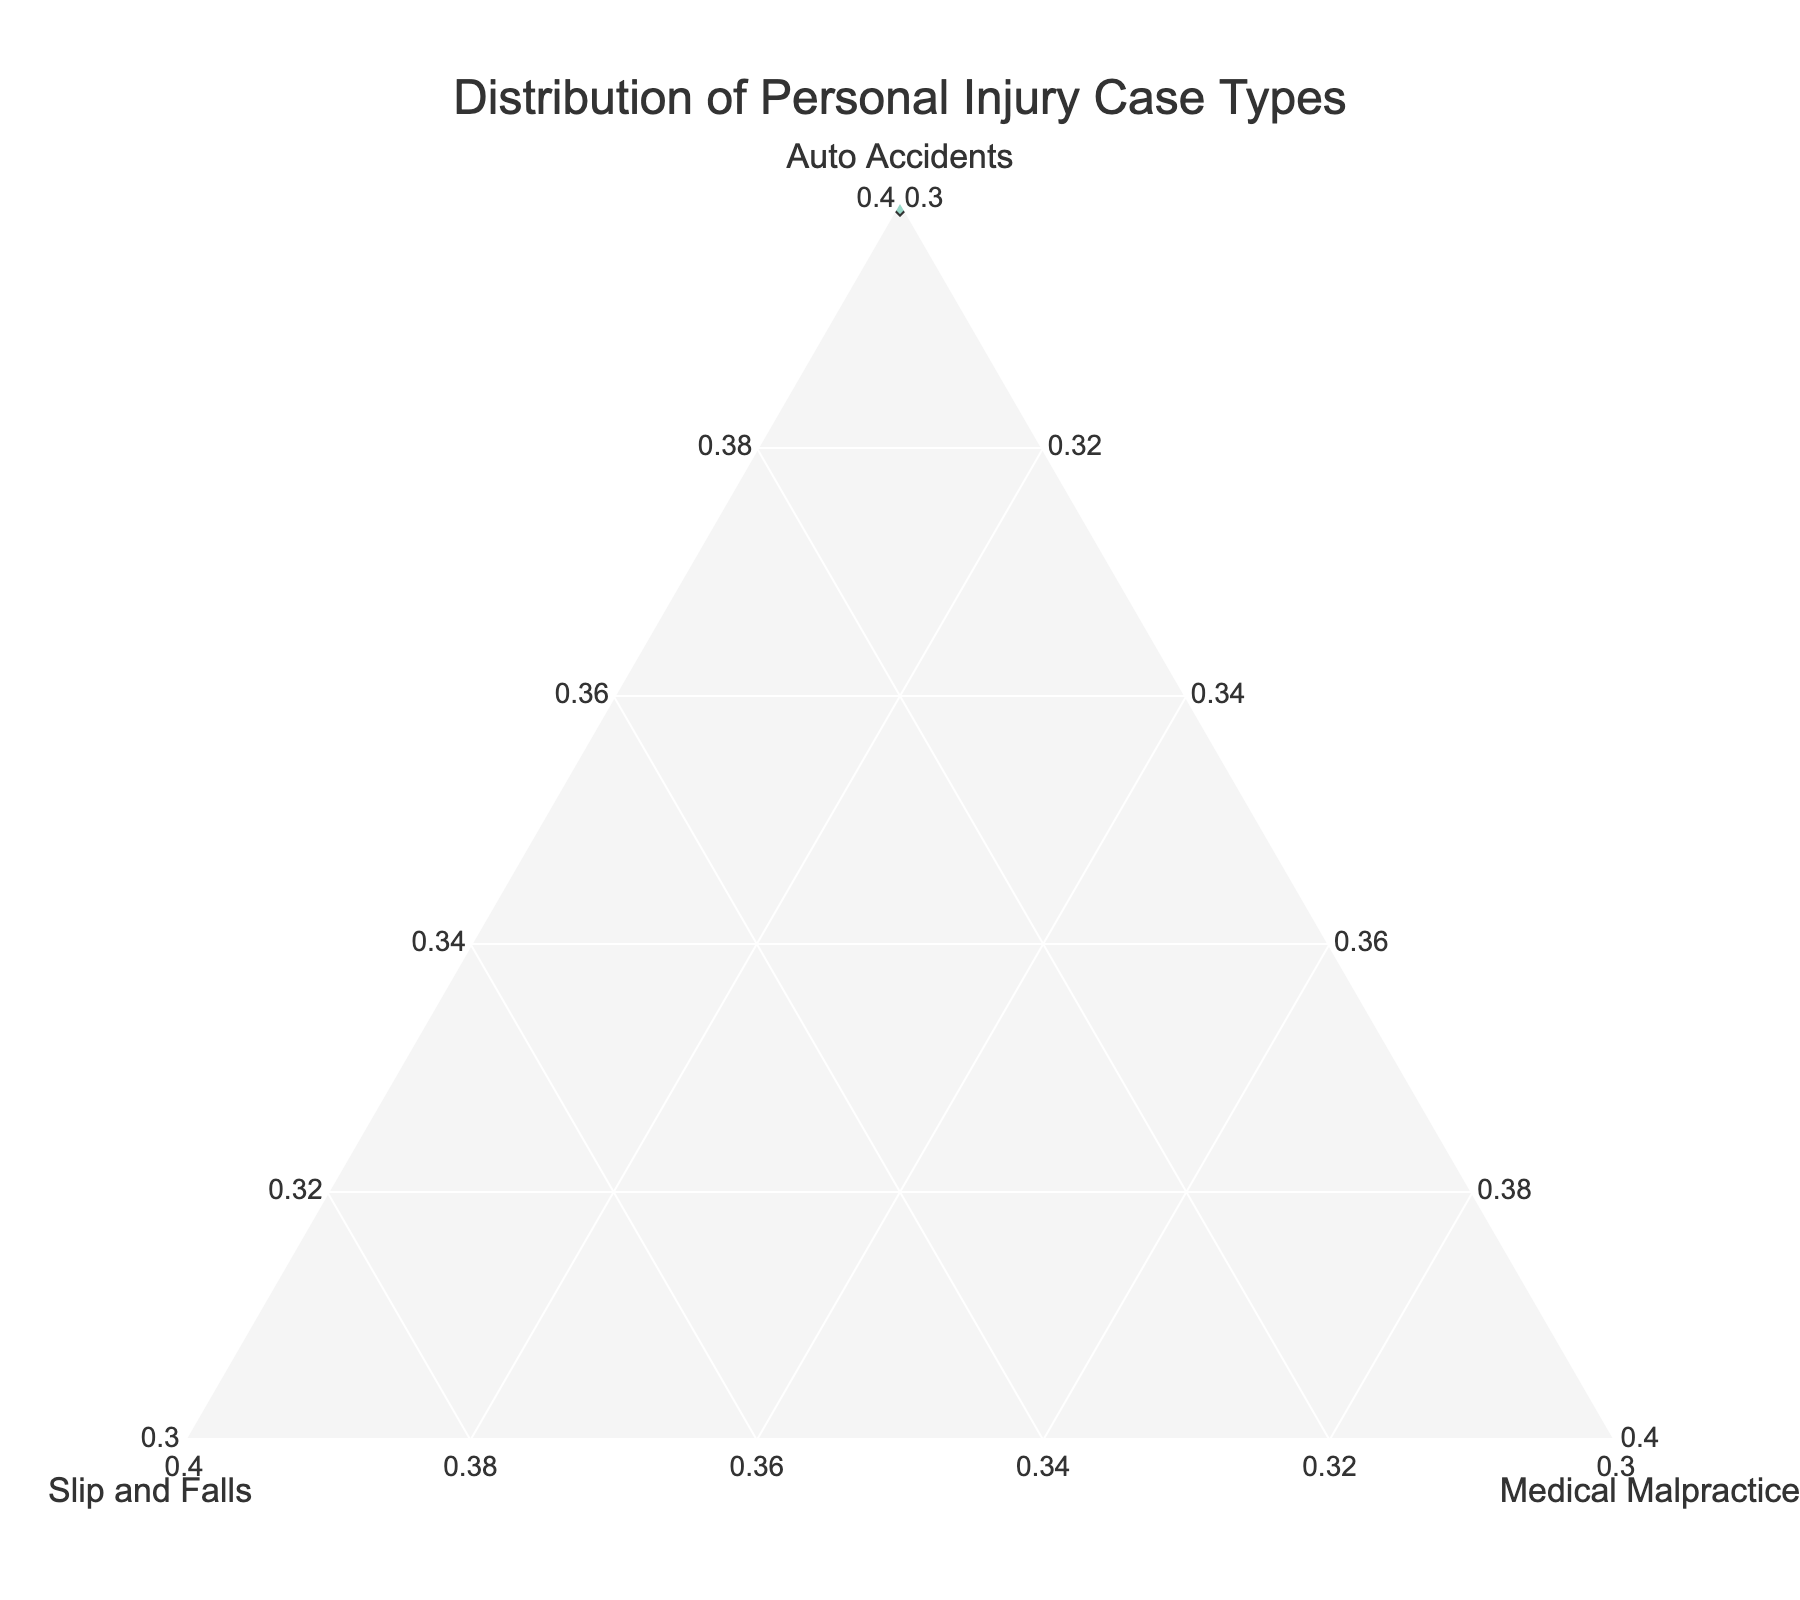What's the title of the ternary plot? The title of a plot is generally at the top and summarizes what the plot represents. In this case, the plot title is "Distribution of Personal Injury Case Types."
Answer: "Distribution of Personal Injury Case Types" How many law firms are plotted in the ternary plot? The figure plots individual data points marked with firm names. By counting these labels, we can determine that there are 10 points.
Answer: 10 Which law firm has the highest percentage of Auto Accidents cases? To determine this, look for the most skewed point towards the "Auto Accidents" axis. The firm "Chen Law Office" has the highest percentage at 65%.
Answer: Chen Law Office What is the proportion of Medical Malpractice cases for the "Goldstein Firm"? Find the "Goldstein Firm" label and check its position with respect to the Medical Malpractice axis. The firm has 30% of its cases in Medical Malpractice.
Answer: 30% Which two law firms have the same percentage of Medical Malpractice cases? Look for firms with identical values on the Medical Malpractice axis. Both "Johnson & Associates" and "Hernandez Law Group" have 15% of their cases in Medical Malpractice.
Answer: Johnson & Associates and Hernandez Law Group Do any law firms have an equal distribution in Slip and Falls and Medical Malpractice cases? Observe the ternary plot and compare values on both "Slip and Falls" and "Medical Malpractice" axes. None of the firms have equal distribution across these two case types.
Answer: No Which law firm has the closest distribution of case types to the center of the plot? The center of the ternary plot represents an equal distribution across all three categories. The "Goldstein Firm" with values (40, 30, 30) appears closest to the center.
Answer: Goldstein Firm Calculate the total percentage of non-Auto Accident cases for "Rodriguez & Partners." Sum the percentages for "Slip and Falls" and "Medical Malpractice." For "Rodriguez & Partners," 35% (Slip and Falls) + 15% (Medical Malpractice) = 50%.
Answer: 50% Compare the proportion of Slip and Falls cases between "Smith Legal Group" and "Clark & Williams." Which one has more, and by how much? The percentage for "Smith Legal Group" is 40%, and for "Clark & Williams" it is 30%. The difference is 40% - 30% = 10%.
Answer: Smith Legal Group, by 10% If you were to average the Auto Accident percentages for all firms, what would be the result? Sum all the percentages and divide by the number of firms: (60 + 45 + 55 + 50 + 40 + 65 + 55 + 45 + 50 + 60) / 10 = 52.5%.
Answer: 52.5% 